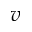Convert formula to latex. <formula><loc_0><loc_0><loc_500><loc_500>v</formula> 